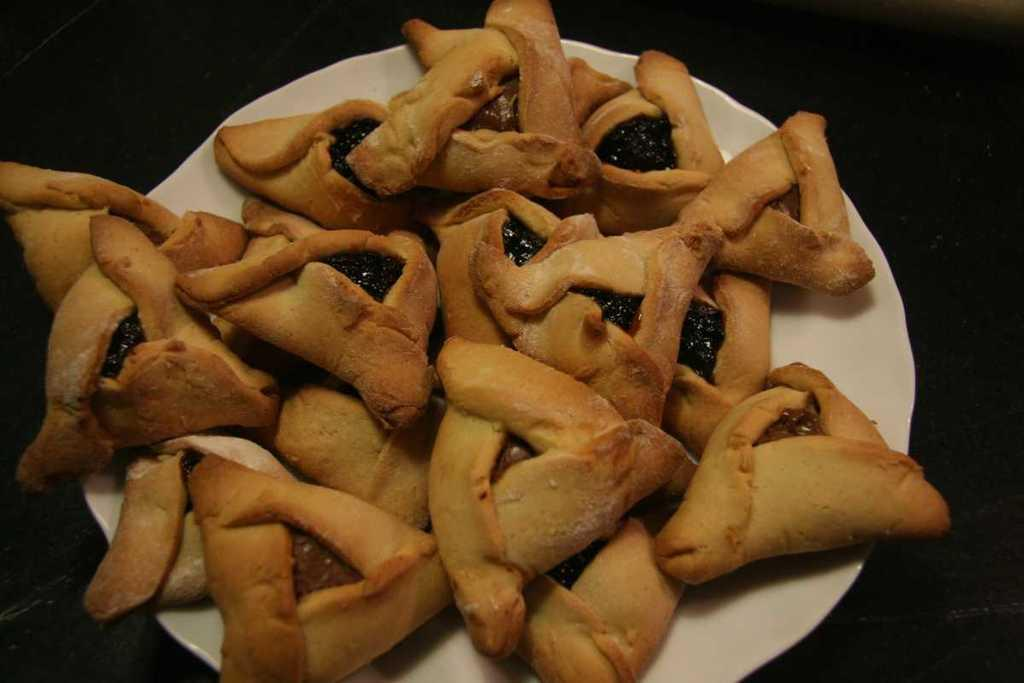What is present on the plate in the image? The plate is filled with food items. Can you describe the food items on the plate? Unfortunately, the specific food items cannot be determined from the provided facts. How many boys are playing in the sleet in the image? There is no mention of boys or sleet in the provided facts, so this question cannot be answered. 